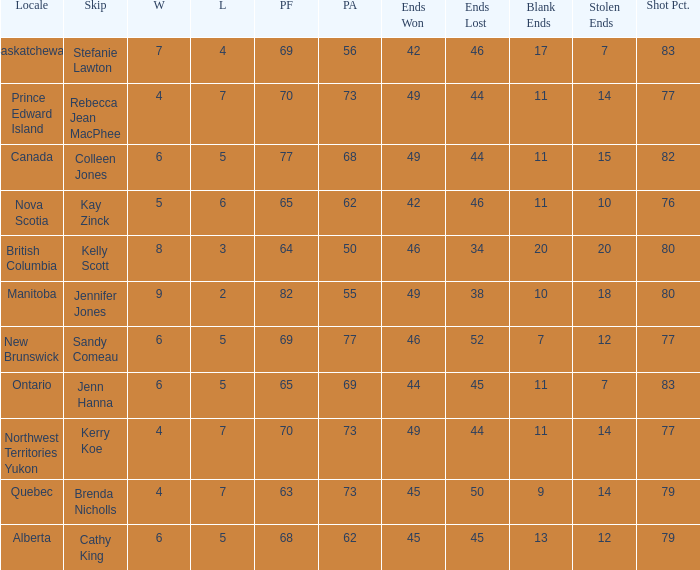What is the minimum PA when ends lost is 45? 62.0. 